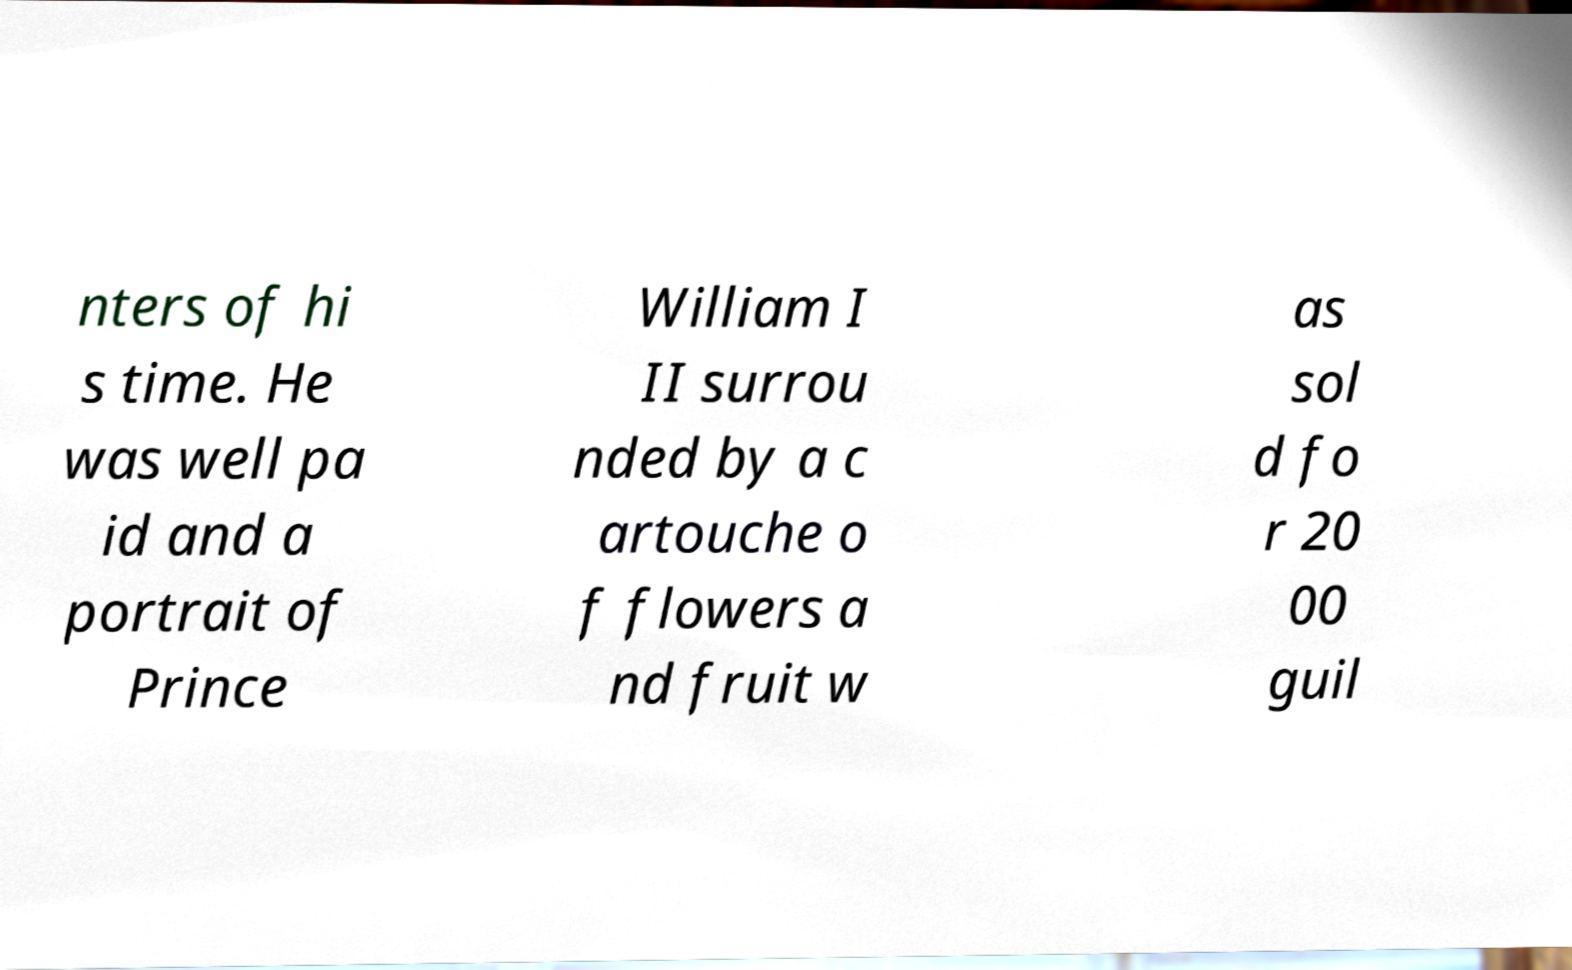Could you extract and type out the text from this image? nters of hi s time. He was well pa id and a portrait of Prince William I II surrou nded by a c artouche o f flowers a nd fruit w as sol d fo r 20 00 guil 